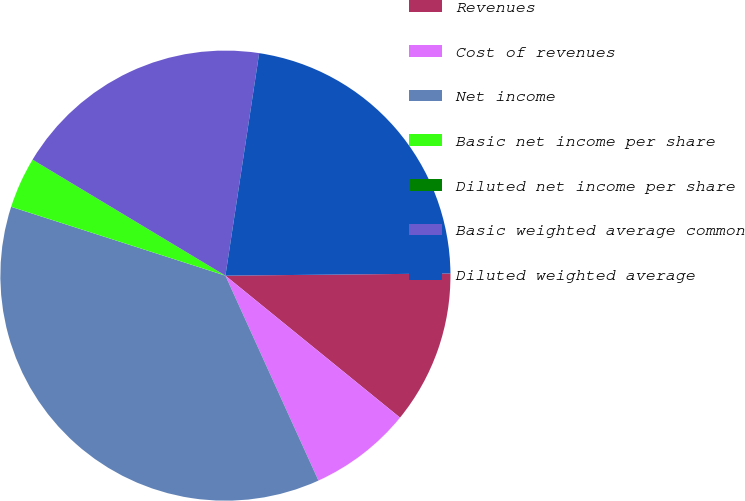<chart> <loc_0><loc_0><loc_500><loc_500><pie_chart><fcel>Revenues<fcel>Cost of revenues<fcel>Net income<fcel>Basic net income per share<fcel>Diluted net income per share<fcel>Basic weighted average common<fcel>Diluted weighted average<nl><fcel>11.02%<fcel>7.35%<fcel>36.73%<fcel>3.67%<fcel>0.0%<fcel>18.78%<fcel>22.45%<nl></chart> 